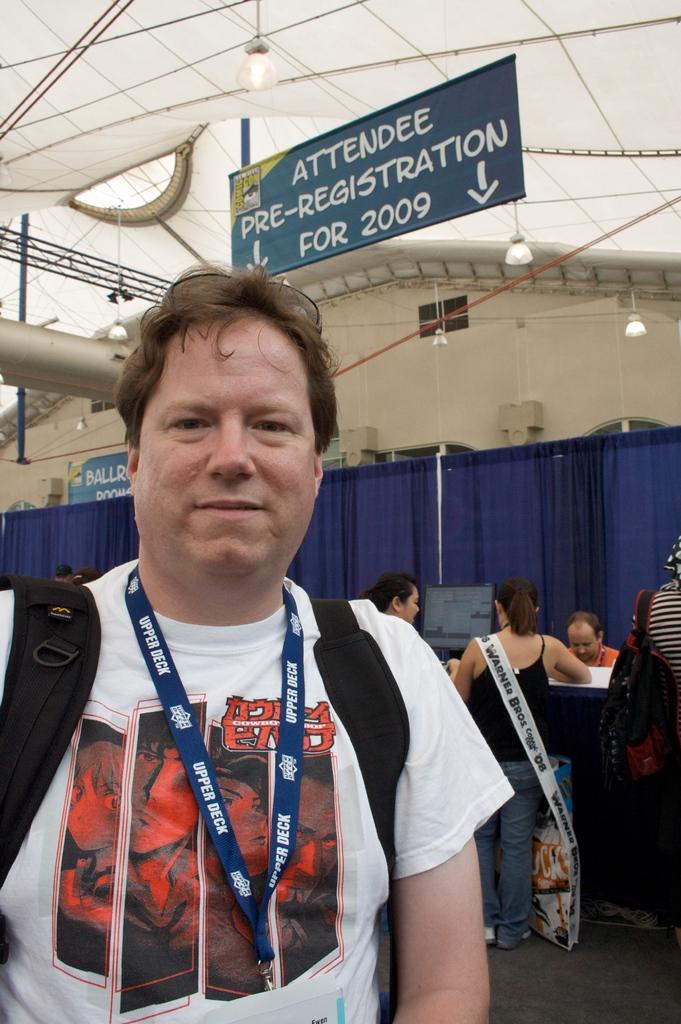What year is cited on the registration banner?
Ensure brevity in your answer.  2009. Who is this pre-registration for?
Offer a very short reply. Attendee. 